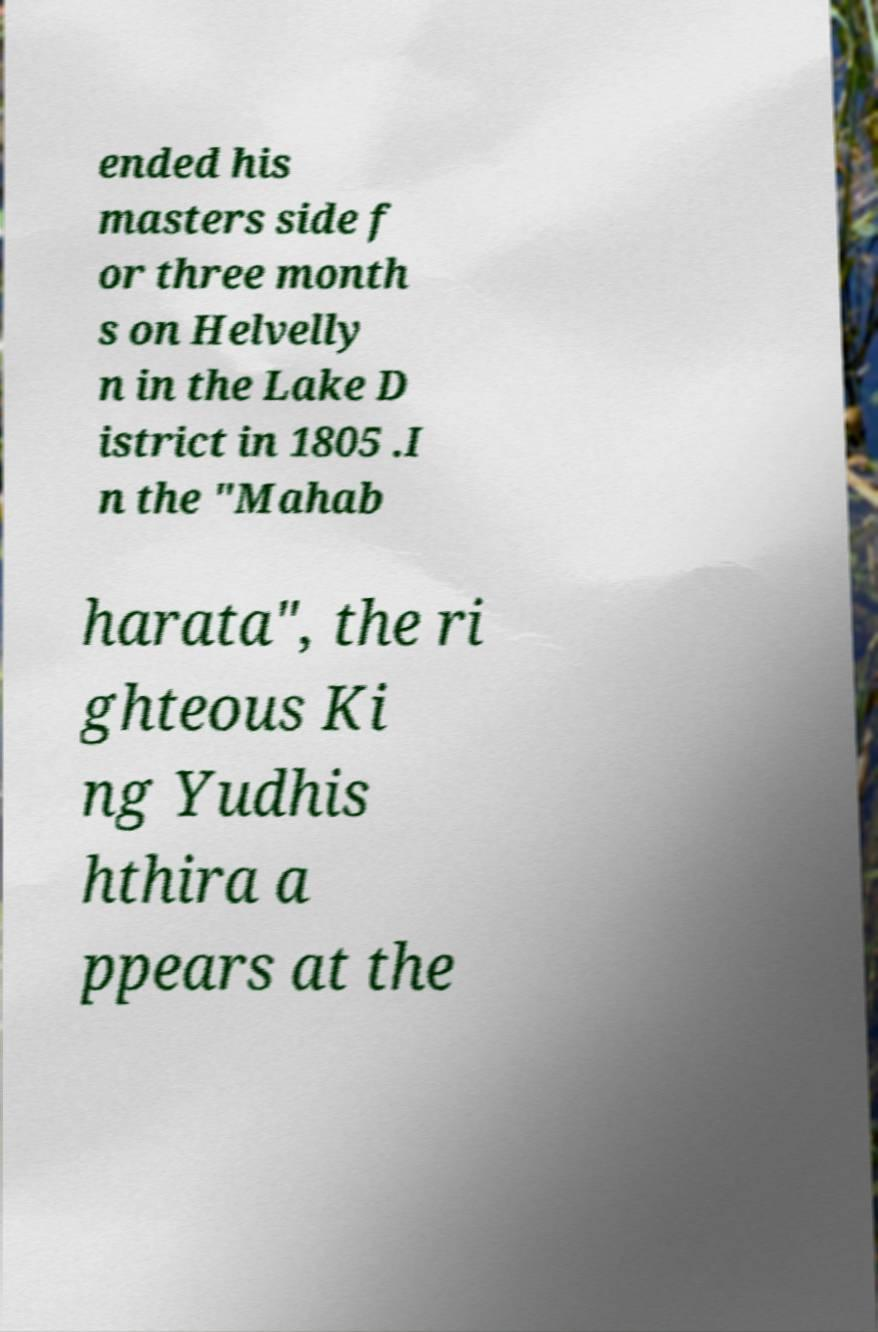Can you accurately transcribe the text from the provided image for me? ended his masters side f or three month s on Helvelly n in the Lake D istrict in 1805 .I n the "Mahab harata", the ri ghteous Ki ng Yudhis hthira a ppears at the 